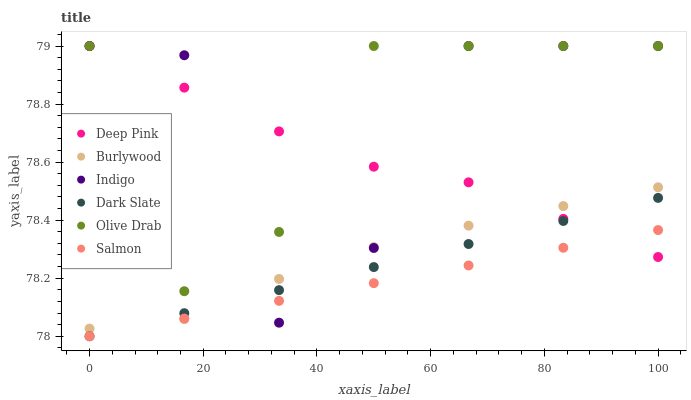Does Salmon have the minimum area under the curve?
Answer yes or no. Yes. Does Olive Drab have the maximum area under the curve?
Answer yes or no. Yes. Does Indigo have the minimum area under the curve?
Answer yes or no. No. Does Indigo have the maximum area under the curve?
Answer yes or no. No. Is Salmon the smoothest?
Answer yes or no. Yes. Is Indigo the roughest?
Answer yes or no. Yes. Is Burlywood the smoothest?
Answer yes or no. No. Is Burlywood the roughest?
Answer yes or no. No. Does Salmon have the lowest value?
Answer yes or no. Yes. Does Indigo have the lowest value?
Answer yes or no. No. Does Olive Drab have the highest value?
Answer yes or no. Yes. Does Burlywood have the highest value?
Answer yes or no. No. Is Burlywood less than Olive Drab?
Answer yes or no. Yes. Is Olive Drab greater than Dark Slate?
Answer yes or no. Yes. Does Salmon intersect Dark Slate?
Answer yes or no. Yes. Is Salmon less than Dark Slate?
Answer yes or no. No. Is Salmon greater than Dark Slate?
Answer yes or no. No. Does Burlywood intersect Olive Drab?
Answer yes or no. No. 